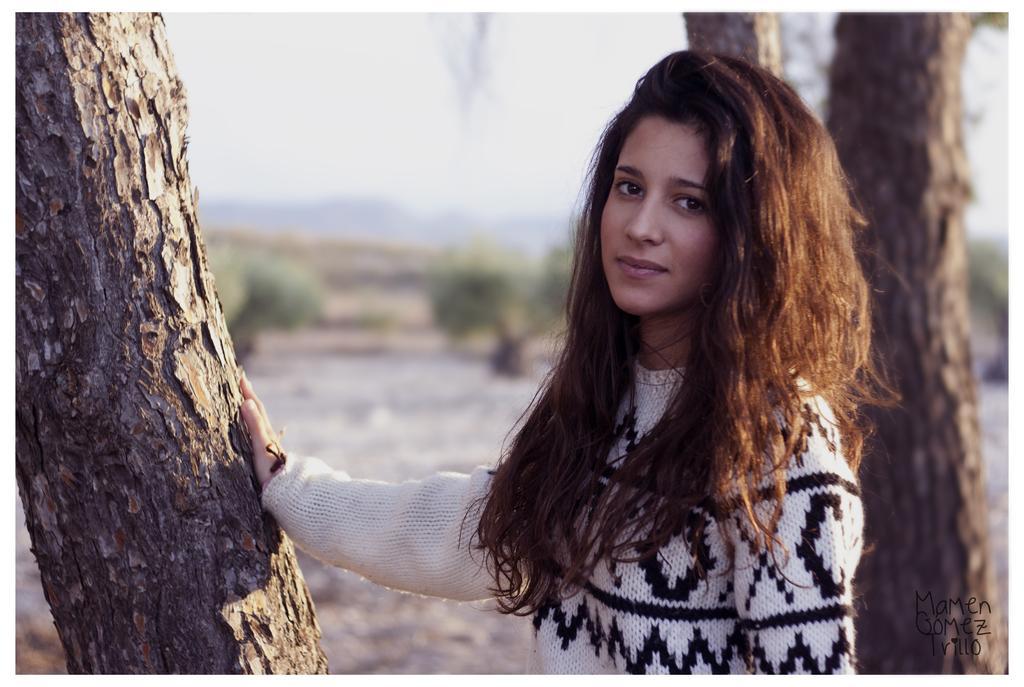In one or two sentences, can you explain what this image depicts? In this image we can see a woman. She is wearing a sweater. We can see a bark of a tree on the left side of the image. In the background, we can see trees, land and the sky. 